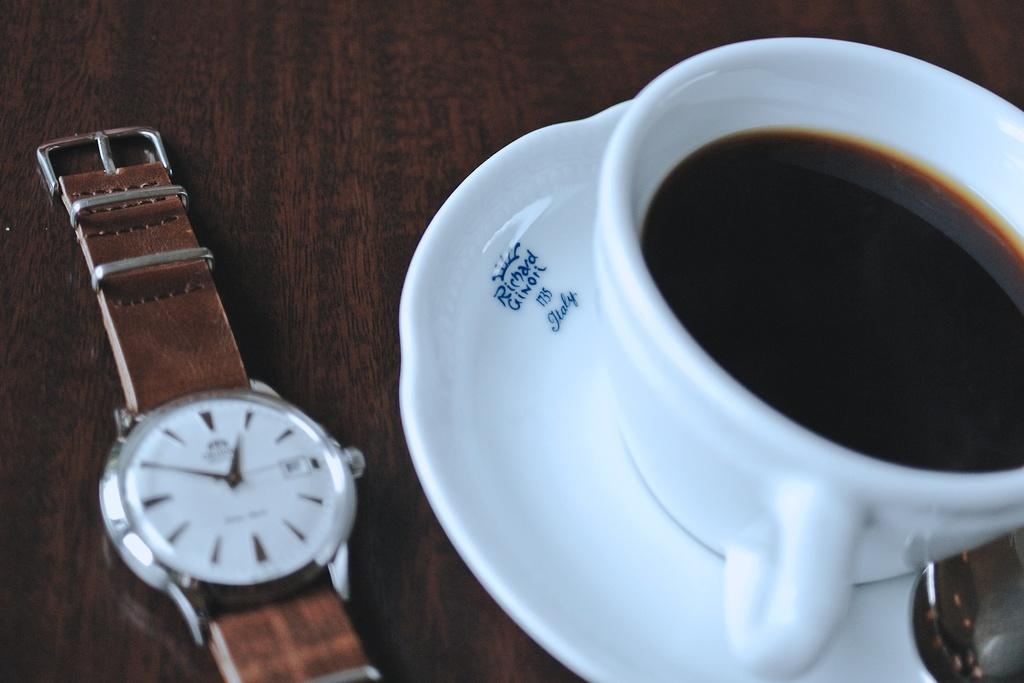<image>
Share a concise interpretation of the image provided. A watch next to a plate that says it was made in italy on it. 